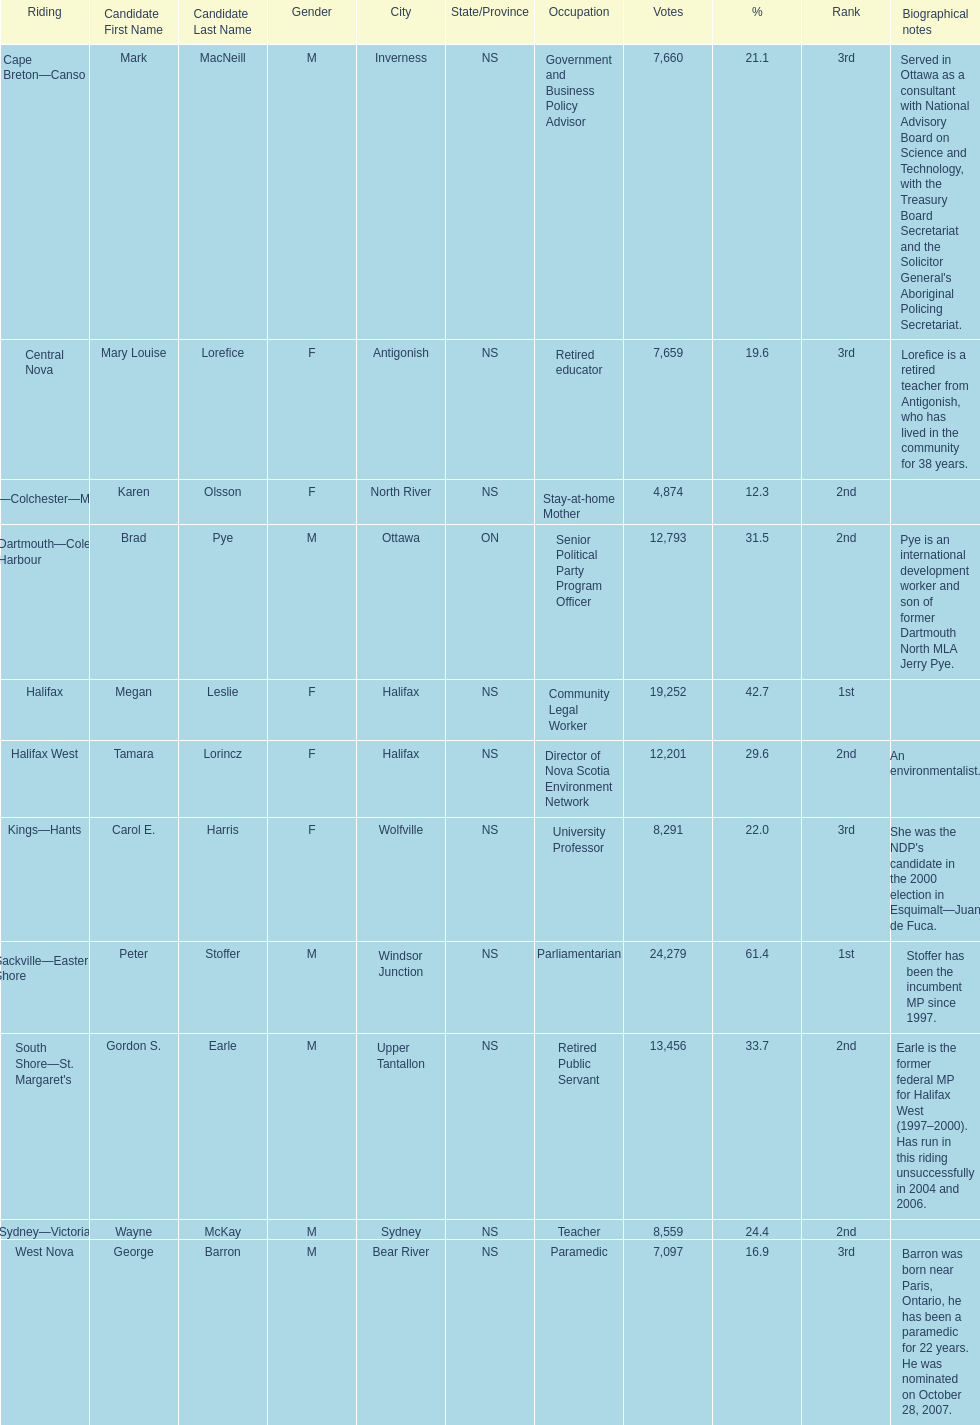How many candidates were from halifax? 2. 